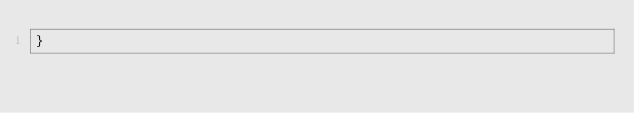Convert code to text. <code><loc_0><loc_0><loc_500><loc_500><_CSS_>}</code> 